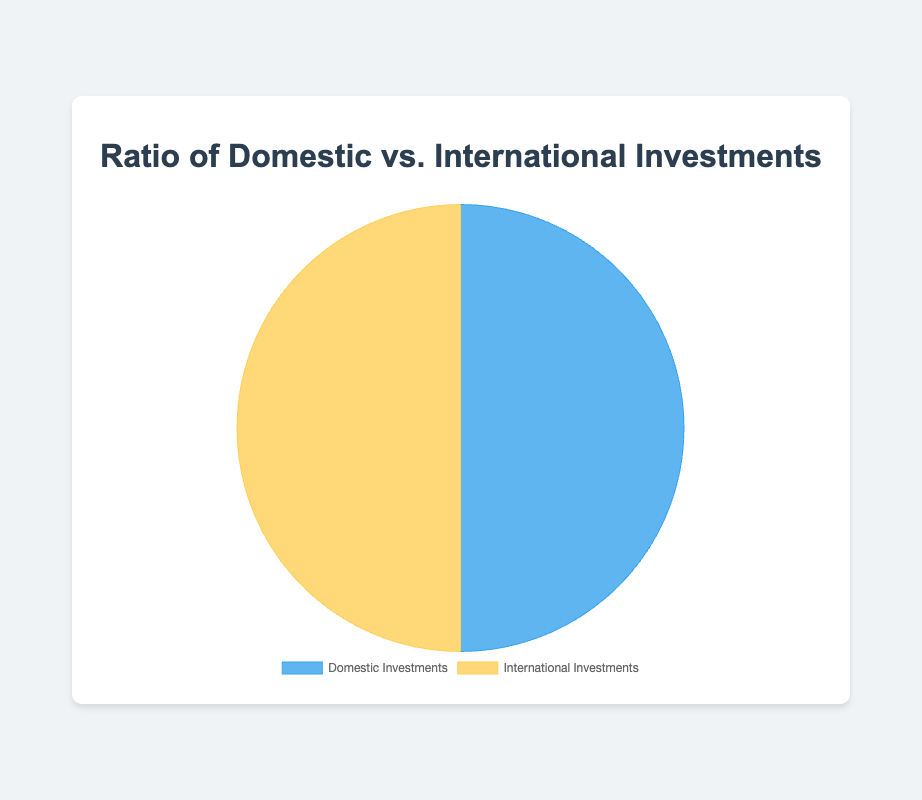How much of the portfolio is allocated to Domestic Investments? By adding up the US Stocks and US Bonds, we get 40 + 10.
Answer: 50 How much of the portfolio is allocated to International Investments? By adding up the Developed Markets and Emerging Markets, we get 30 + 20.
Answer: 50 What percentage of the total portfolio is Domestic Investments? The total portfolio is 100% and Domestic Investments are 50, so the percentage is (50 / 100) * 100.
Answer: 50% Which category has a larger allocation: Domestic Investments or International Investments? Both Domestic Investments and International Investments have the same allocation of 50.
Answer: Neither, they are equal What is the combined allocation of US Stocks and Developed Markets? Adding US Stocks and Developed Markets, we get 40 + 30.
Answer: 70 What percentage of the total portfolio is Emerging Markets? The total portfolio is 100 and Emerging Markets are 20, so the percentage is (20 / 100) * 100.
Answer: 20% Which has a higher allocation in the Domestic Investments category: US Stocks or US Bonds? US Stocks have 40, and US Bonds have 10. 40 is greater than 10.
Answer: US Stocks What is the difference in percentage allocation between Developed Markets and Emerging Markets? Developed Markets are 30 and Emerging Markets are 20. The difference is 30 - 20.
Answer: 10 If the total portfolio were to increase by 20%, what would be the new allocation for International Investments if proportions remain the same? The original total is 100. A 20% increase would make it 120. International Investments originally are 50% of the portfolio, so the new allocation is 120 * 0.5.
Answer: 60 